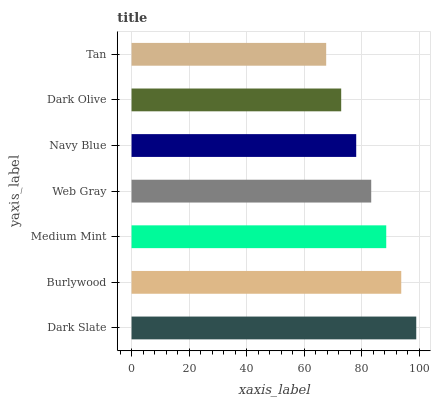Is Tan the minimum?
Answer yes or no. Yes. Is Dark Slate the maximum?
Answer yes or no. Yes. Is Burlywood the minimum?
Answer yes or no. No. Is Burlywood the maximum?
Answer yes or no. No. Is Dark Slate greater than Burlywood?
Answer yes or no. Yes. Is Burlywood less than Dark Slate?
Answer yes or no. Yes. Is Burlywood greater than Dark Slate?
Answer yes or no. No. Is Dark Slate less than Burlywood?
Answer yes or no. No. Is Web Gray the high median?
Answer yes or no. Yes. Is Web Gray the low median?
Answer yes or no. Yes. Is Tan the high median?
Answer yes or no. No. Is Dark Slate the low median?
Answer yes or no. No. 